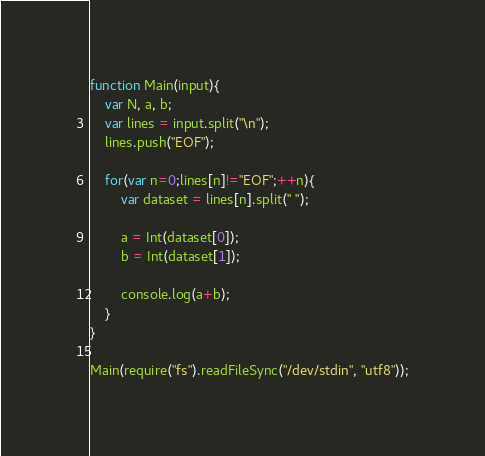Convert code to text. <code><loc_0><loc_0><loc_500><loc_500><_JavaScript_>function Main(input){
    var N, a, b;
    var lines = input.split("\n");
    lines.push("EOF");
    
    for(var n=0;lines[n]!="EOF";++n){
        var dataset = lines[n].split(" ");
        
        a = Int(dataset[0]);
        b = Int(dataset[1]);
        
        console.log(a+b);
    }
}

Main(require("fs").readFileSync("/dev/stdin", "utf8"));</code> 